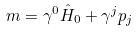Convert formula to latex. <formula><loc_0><loc_0><loc_500><loc_500>m = \gamma ^ { 0 } \hat { H } _ { 0 } + \gamma ^ { j } p _ { j }</formula> 